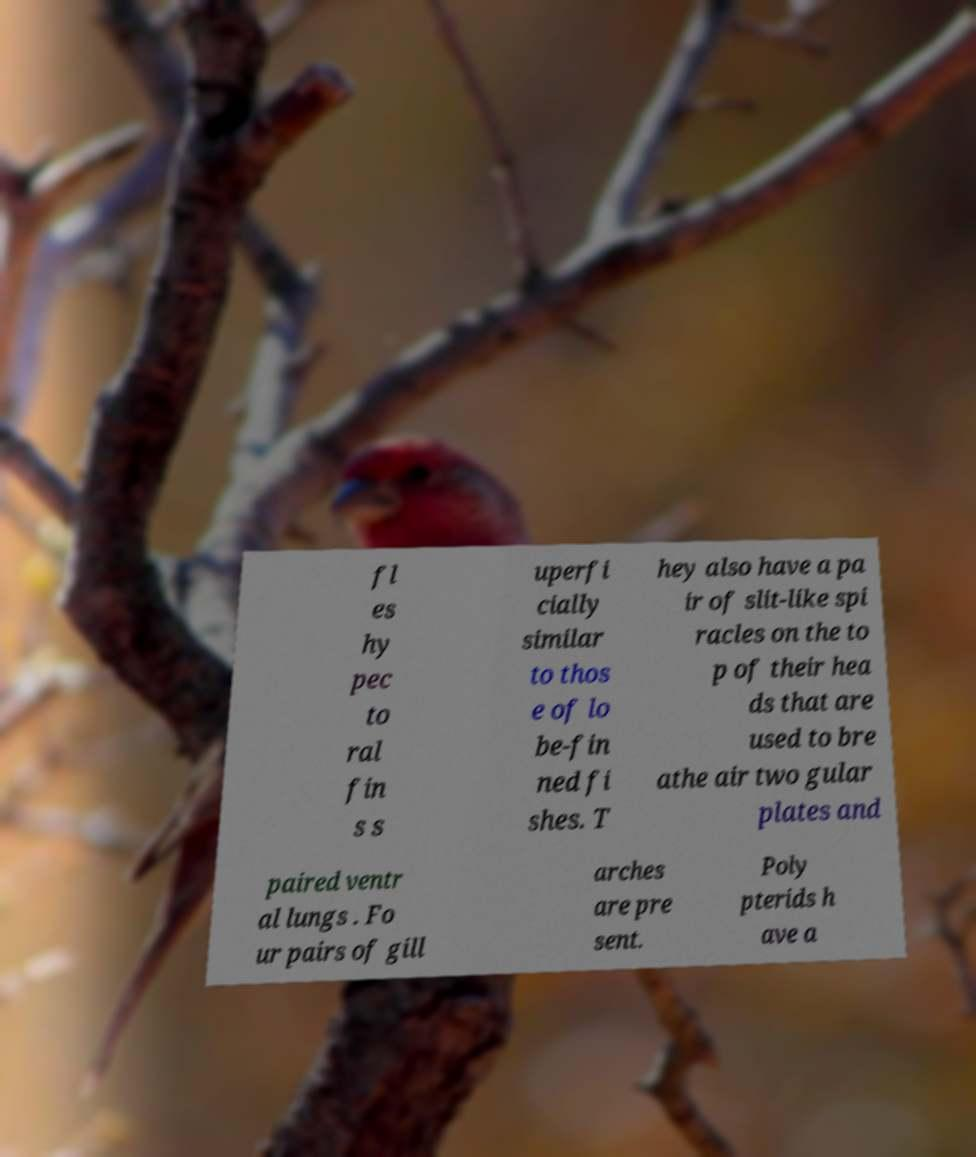Can you read and provide the text displayed in the image?This photo seems to have some interesting text. Can you extract and type it out for me? fl es hy pec to ral fin s s uperfi cially similar to thos e of lo be-fin ned fi shes. T hey also have a pa ir of slit-like spi racles on the to p of their hea ds that are used to bre athe air two gular plates and paired ventr al lungs . Fo ur pairs of gill arches are pre sent. Poly pterids h ave a 